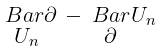<formula> <loc_0><loc_0><loc_500><loc_500>\begin{smallmatrix} \ B a r { \partial } & - \ B a r { U } _ { n } \\ U _ { n } & \partial \end{smallmatrix}</formula> 